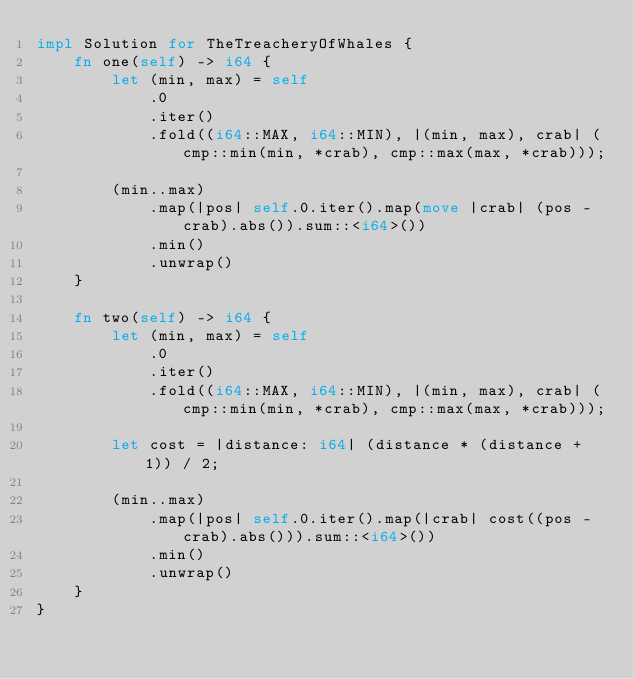Convert code to text. <code><loc_0><loc_0><loc_500><loc_500><_Rust_>impl Solution for TheTreacheryOfWhales {
    fn one(self) -> i64 {
        let (min, max) = self
            .0
            .iter()
            .fold((i64::MAX, i64::MIN), |(min, max), crab| (cmp::min(min, *crab), cmp::max(max, *crab)));

        (min..max)
            .map(|pos| self.0.iter().map(move |crab| (pos - crab).abs()).sum::<i64>())
            .min()
            .unwrap()
    }

    fn two(self) -> i64 {
        let (min, max) = self
            .0
            .iter()
            .fold((i64::MAX, i64::MIN), |(min, max), crab| (cmp::min(min, *crab), cmp::max(max, *crab)));

        let cost = |distance: i64| (distance * (distance + 1)) / 2;

        (min..max)
            .map(|pos| self.0.iter().map(|crab| cost((pos - crab).abs())).sum::<i64>())
            .min()
            .unwrap()
    }
}
</code> 